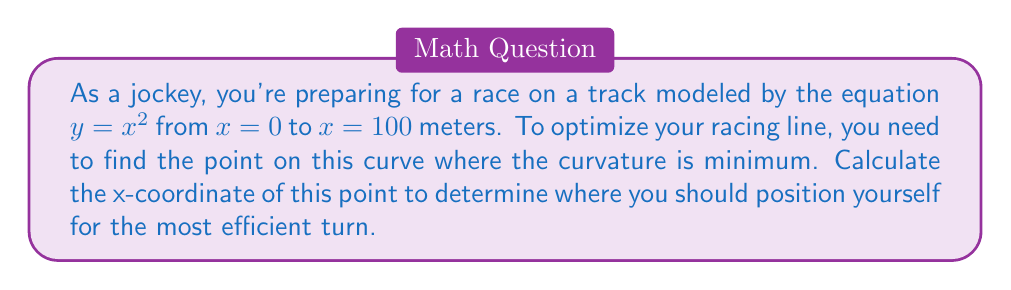Can you answer this question? Let's approach this step-by-step:

1) The curvature of a curve $y = f(x)$ is given by the formula:

   $$\kappa = \frac{|f''(x)|}{(1 + [f'(x)]^2)^{3/2}}$$

2) For our curve $y = x^2$, we need to find $f'(x)$ and $f''(x)$:
   
   $f'(x) = 2x$
   $f''(x) = 2$

3) Substituting these into the curvature formula:

   $$\kappa = \frac{|2|}{(1 + [2x]^2)^{3/2}}$$

4) To find the minimum curvature, we need to maximize the denominator $(1 + [2x]^2)^{3/2}$

5) The denominator will be at its maximum when $x$ is at its maximum value within the given range.

6) The maximum value of $x$ is given as 100 meters.

Therefore, the point of minimum curvature occurs at $x = 100$ meters.

[asy]
size(200,200);
real f(real x) {return x^2/400;}
draw(graph(f,0,10),blue);
dot((10,f(10)),red);
label("(100, 10000)",align=E,(10,f(10)));
xaxis("x",arrow=Arrow);
yaxis("y",arrow=Arrow);
[/asy]
Answer: $x = 100$ meters 